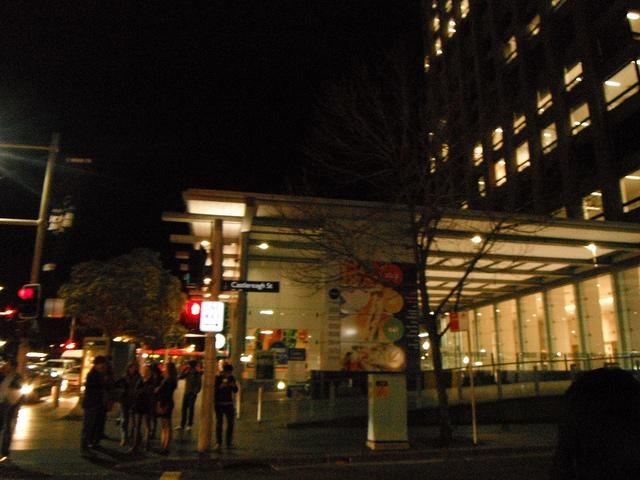What are the people waiting to do?

Choices:
A) eat
B) work
C) speak
D) cross cross 